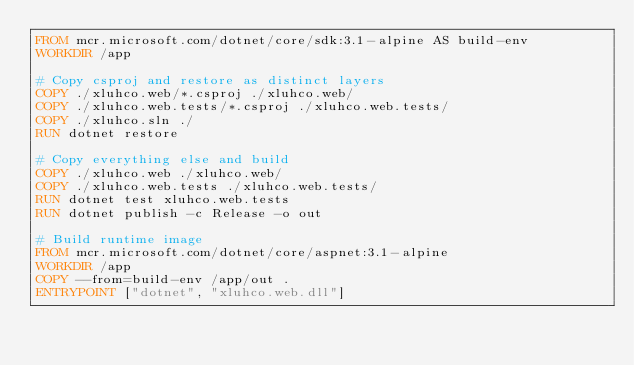<code> <loc_0><loc_0><loc_500><loc_500><_Dockerfile_>FROM mcr.microsoft.com/dotnet/core/sdk:3.1-alpine AS build-env
WORKDIR /app

# Copy csproj and restore as distinct layers
COPY ./xluhco.web/*.csproj ./xluhco.web/
COPY ./xluhco.web.tests/*.csproj ./xluhco.web.tests/
COPY ./xluhco.sln ./
RUN dotnet restore

# Copy everything else and build
COPY ./xluhco.web ./xluhco.web/
COPY ./xluhco.web.tests ./xluhco.web.tests/
RUN dotnet test xluhco.web.tests
RUN dotnet publish -c Release -o out

# Build runtime image
FROM mcr.microsoft.com/dotnet/core/aspnet:3.1-alpine
WORKDIR /app
COPY --from=build-env /app/out .
ENTRYPOINT ["dotnet", "xluhco.web.dll"]</code> 